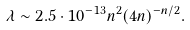<formula> <loc_0><loc_0><loc_500><loc_500>\lambda \sim 2 . 5 \cdot 1 0 ^ { - 1 3 } n ^ { 2 } ( 4 n ) ^ { - n / 2 } .</formula> 